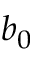Convert formula to latex. <formula><loc_0><loc_0><loc_500><loc_500>b _ { 0 }</formula> 